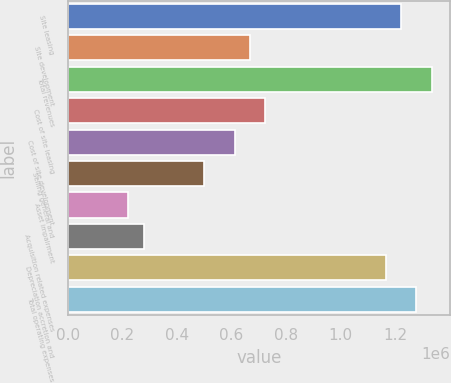Convert chart. <chart><loc_0><loc_0><loc_500><loc_500><bar_chart><fcel>Site leasing<fcel>Site development<fcel>Total revenues<fcel>Cost of site leasing<fcel>Cost of site development<fcel>Selling general and<fcel>Asset impairment<fcel>Acquisition related expenses<fcel>Depreciation accretion and<fcel>Total operating expenses<nl><fcel>1.22213e+06<fcel>666615<fcel>1.33323e+06<fcel>722167<fcel>611064<fcel>499962<fcel>222206<fcel>277757<fcel>1.16658e+06<fcel>1.27768e+06<nl></chart> 